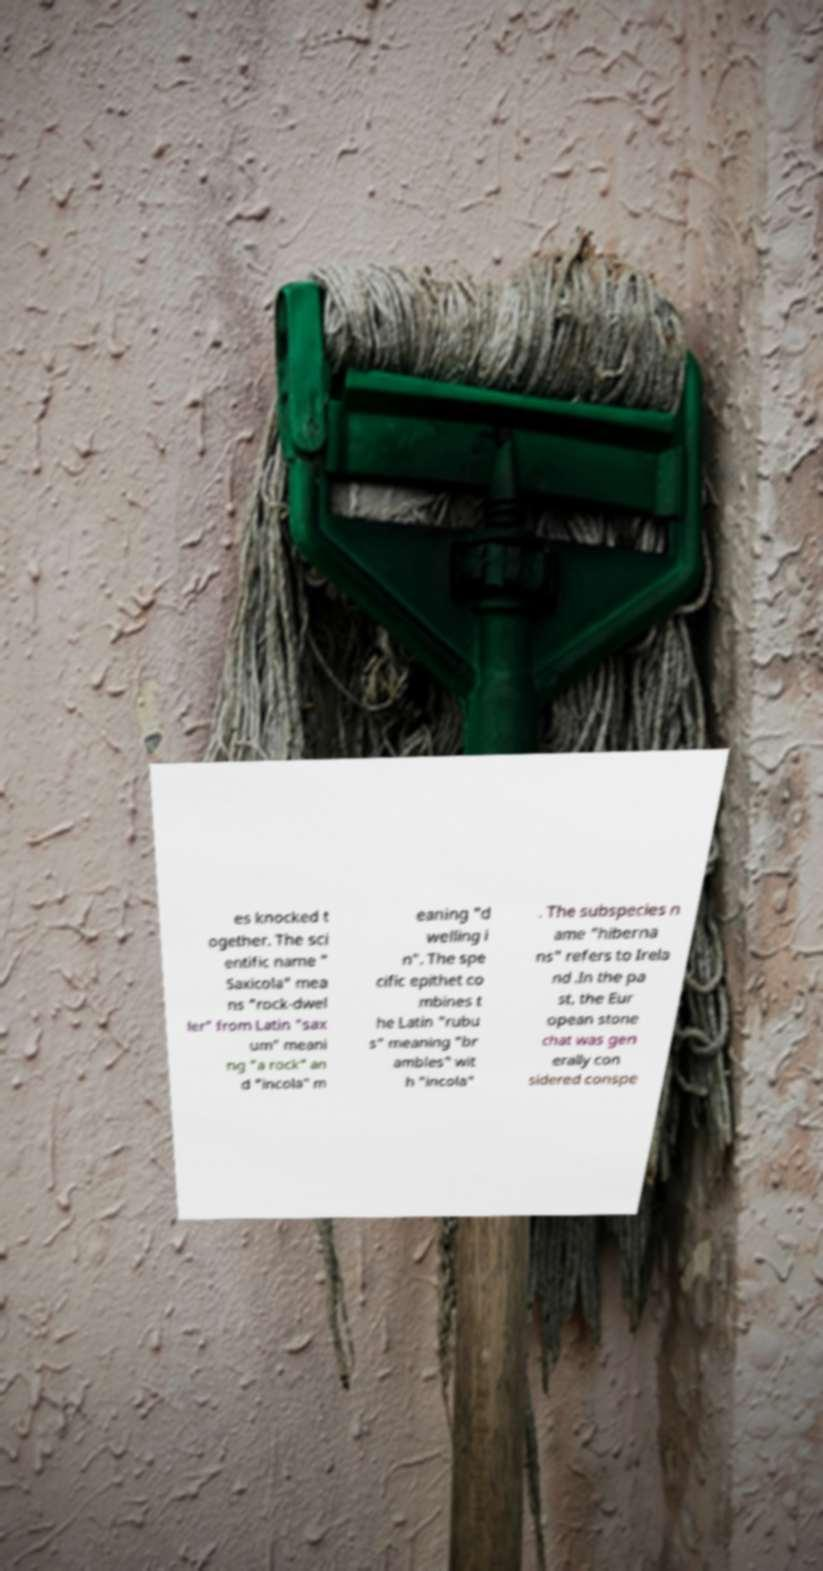For documentation purposes, I need the text within this image transcribed. Could you provide that? es knocked t ogether. The sci entific name " Saxicola" mea ns "rock-dwel ler" from Latin "sax um" meani ng "a rock" an d "incola" m eaning "d welling i n". The spe cific epithet co mbines t he Latin "rubu s" meaning "br ambles" wit h "incola" . The subspecies n ame "hiberna ns" refers to Irela nd .In the pa st, the Eur opean stone chat was gen erally con sidered conspe 